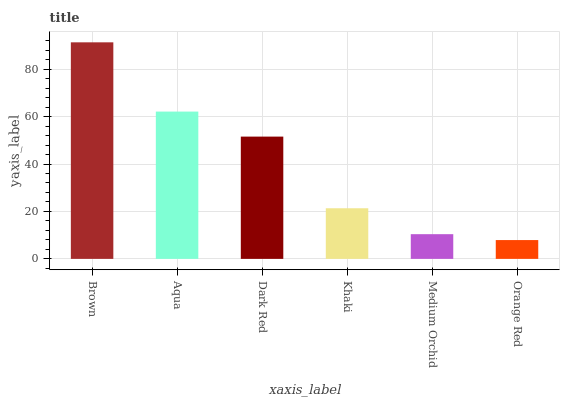Is Orange Red the minimum?
Answer yes or no. Yes. Is Brown the maximum?
Answer yes or no. Yes. Is Aqua the minimum?
Answer yes or no. No. Is Aqua the maximum?
Answer yes or no. No. Is Brown greater than Aqua?
Answer yes or no. Yes. Is Aqua less than Brown?
Answer yes or no. Yes. Is Aqua greater than Brown?
Answer yes or no. No. Is Brown less than Aqua?
Answer yes or no. No. Is Dark Red the high median?
Answer yes or no. Yes. Is Khaki the low median?
Answer yes or no. Yes. Is Orange Red the high median?
Answer yes or no. No. Is Brown the low median?
Answer yes or no. No. 